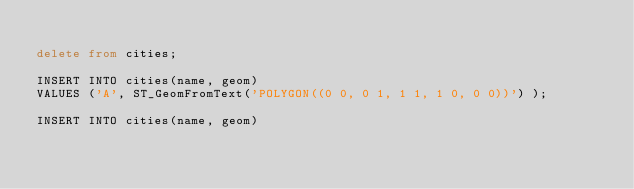<code> <loc_0><loc_0><loc_500><loc_500><_SQL_>
delete from cities;

INSERT INTO cities(name, geom)
VALUES ('A', ST_GeomFromText('POLYGON((0 0, 0 1, 1 1, 1 0, 0 0))') );

INSERT INTO cities(name, geom)</code> 